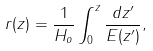Convert formula to latex. <formula><loc_0><loc_0><loc_500><loc_500>r ( z ) = \frac { 1 } { H _ { o } } \int _ { 0 } ^ { z } \frac { d z ^ { \prime } } { E ( z ^ { \prime } ) } ,</formula> 